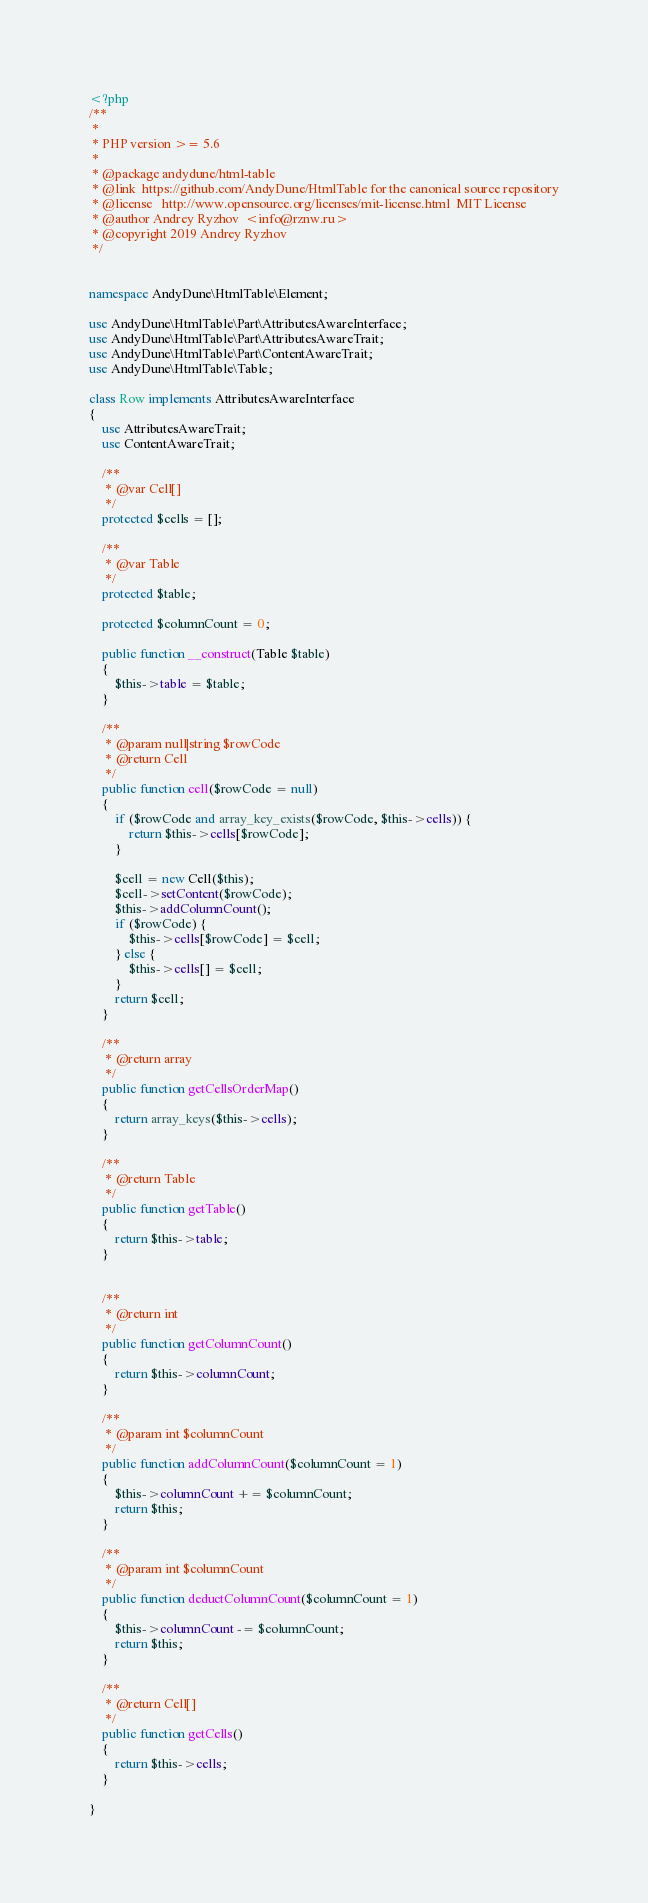Convert code to text. <code><loc_0><loc_0><loc_500><loc_500><_PHP_><?php
/**
 *
 * PHP version >= 5.6
 *
 * @package andydune/html-table
 * @link  https://github.com/AndyDune/HtmlTable for the canonical source repository
 * @license   http://www.opensource.org/licenses/mit-license.html  MIT License
 * @author Andrey Ryzhov  <info@rznw.ru>
 * @copyright 2019 Andrey Ryzhov
 */


namespace AndyDune\HtmlTable\Element;

use AndyDune\HtmlTable\Part\AttributesAwareInterface;
use AndyDune\HtmlTable\Part\AttributesAwareTrait;
use AndyDune\HtmlTable\Part\ContentAwareTrait;
use AndyDune\HtmlTable\Table;

class Row implements AttributesAwareInterface
{
    use AttributesAwareTrait;
    use ContentAwareTrait;

    /**
     * @var Cell[]
     */
    protected $cells = [];

    /**
     * @var Table
     */
    protected $table;

    protected $columnCount = 0;

    public function __construct(Table $table)
    {
        $this->table = $table;
    }

    /**
     * @param null|string $rowCode
     * @return Cell
     */
    public function cell($rowCode = null)
    {
        if ($rowCode and array_key_exists($rowCode, $this->cells)) {
            return $this->cells[$rowCode];
        }

        $cell = new Cell($this);
        $cell->setContent($rowCode);
        $this->addColumnCount();
        if ($rowCode) {
            $this->cells[$rowCode] = $cell;
        } else {
            $this->cells[] = $cell;
        }
        return $cell;
    }

    /**
     * @return array
     */
    public function getCellsOrderMap()
    {
        return array_keys($this->cells);
    }

    /**
     * @return Table
     */
    public function getTable()
    {
        return $this->table;
    }


    /**
     * @return int
     */
    public function getColumnCount()
    {
        return $this->columnCount;
    }

    /**
     * @param int $columnCount
     */
    public function addColumnCount($columnCount = 1)
    {
        $this->columnCount += $columnCount;
        return $this;
    }

    /**
     * @param int $columnCount
     */
    public function deductColumnCount($columnCount = 1)
    {
        $this->columnCount -= $columnCount;
        return $this;
    }

    /**
     * @return Cell[]
     */
    public function getCells()
    {
        return $this->cells;
    }

}</code> 